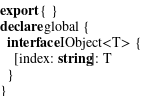Convert code to text. <code><loc_0><loc_0><loc_500><loc_500><_TypeScript_>export { }
declare global {
  interface IObject<T> {
    [index: string]: T
  }
}
</code> 